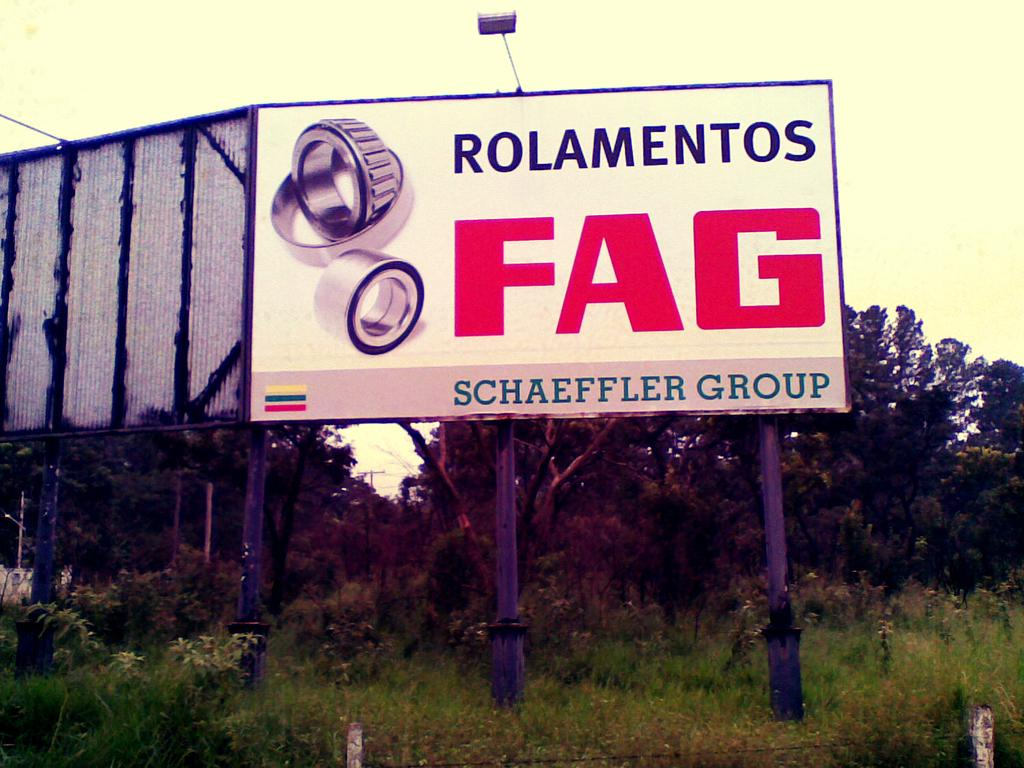<image>
Create a compact narrative representing the image presented. A billboard ad for the Schaeffler Group proclaims ROLAMENTOS FAG. 